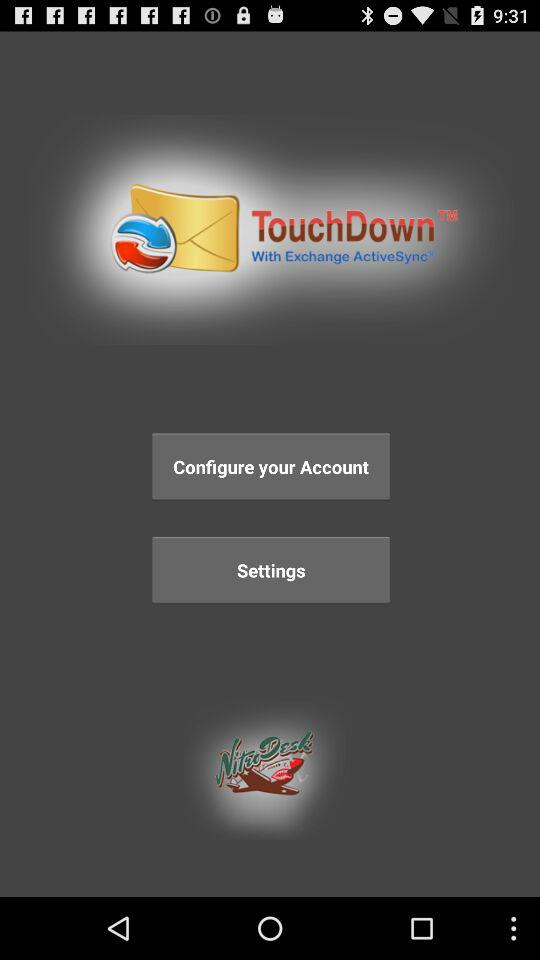What is the application name? The application name is "TouchDown". 